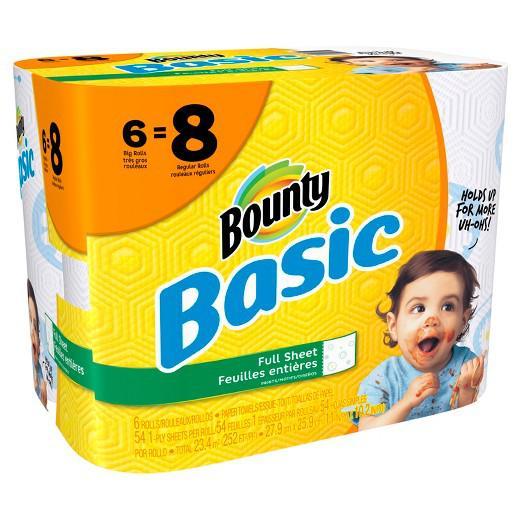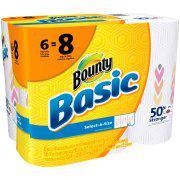The first image is the image on the left, the second image is the image on the right. For the images shown, is this caption "There is a child with a messy face." true? Answer yes or no. Yes. The first image is the image on the left, the second image is the image on the right. Assess this claim about the two images: "The left image contains a multipack of paper towel rolls with a baby's face on the front, and the right image contains packaging with the same color scheme as the left.". Correct or not? Answer yes or no. Yes. 